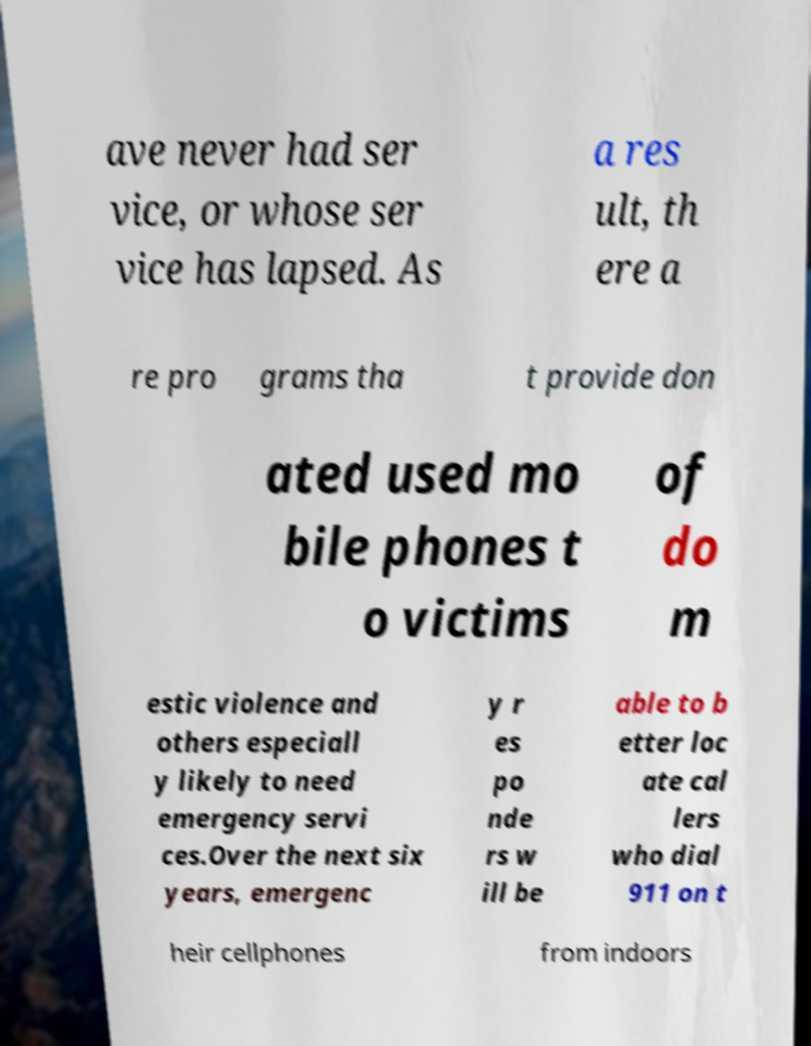Please read and relay the text visible in this image. What does it say? ave never had ser vice, or whose ser vice has lapsed. As a res ult, th ere a re pro grams tha t provide don ated used mo bile phones t o victims of do m estic violence and others especiall y likely to need emergency servi ces.Over the next six years, emergenc y r es po nde rs w ill be able to b etter loc ate cal lers who dial 911 on t heir cellphones from indoors 